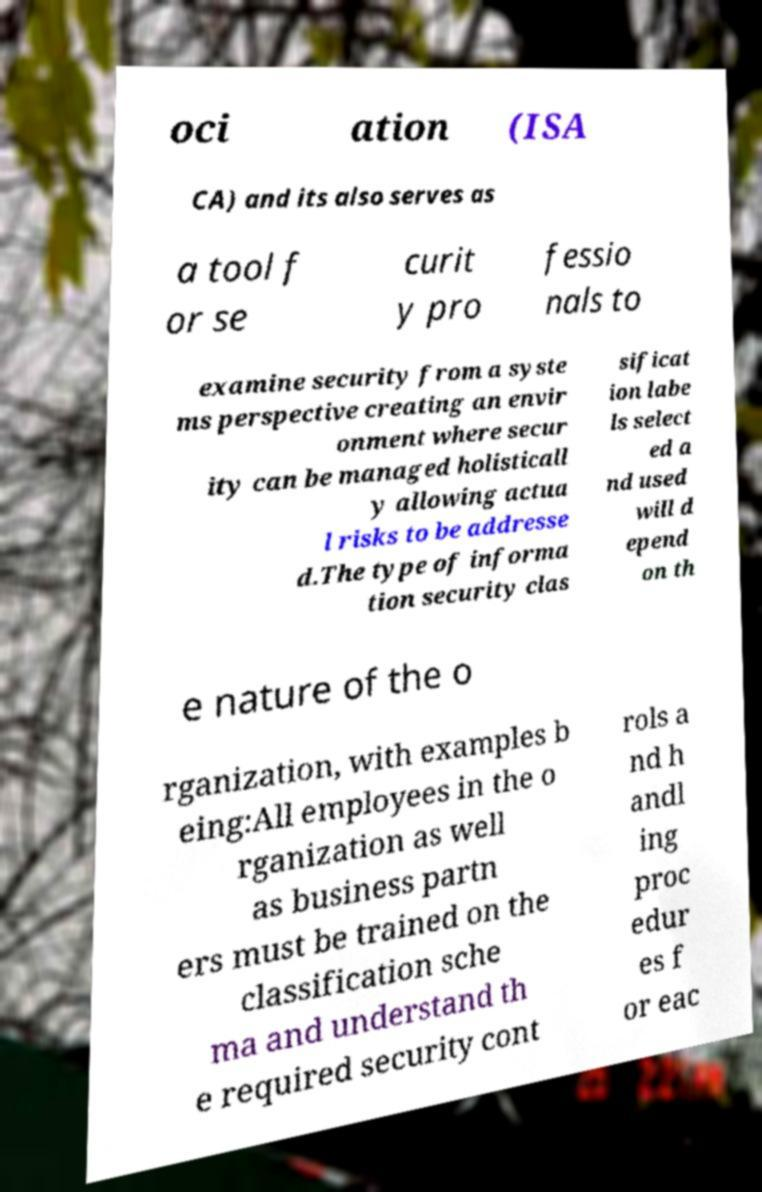Please identify and transcribe the text found in this image. oci ation (ISA CA) and its also serves as a tool f or se curit y pro fessio nals to examine security from a syste ms perspective creating an envir onment where secur ity can be managed holisticall y allowing actua l risks to be addresse d.The type of informa tion security clas sificat ion labe ls select ed a nd used will d epend on th e nature of the o rganization, with examples b eing:All employees in the o rganization as well as business partn ers must be trained on the classification sche ma and understand th e required security cont rols a nd h andl ing proc edur es f or eac 